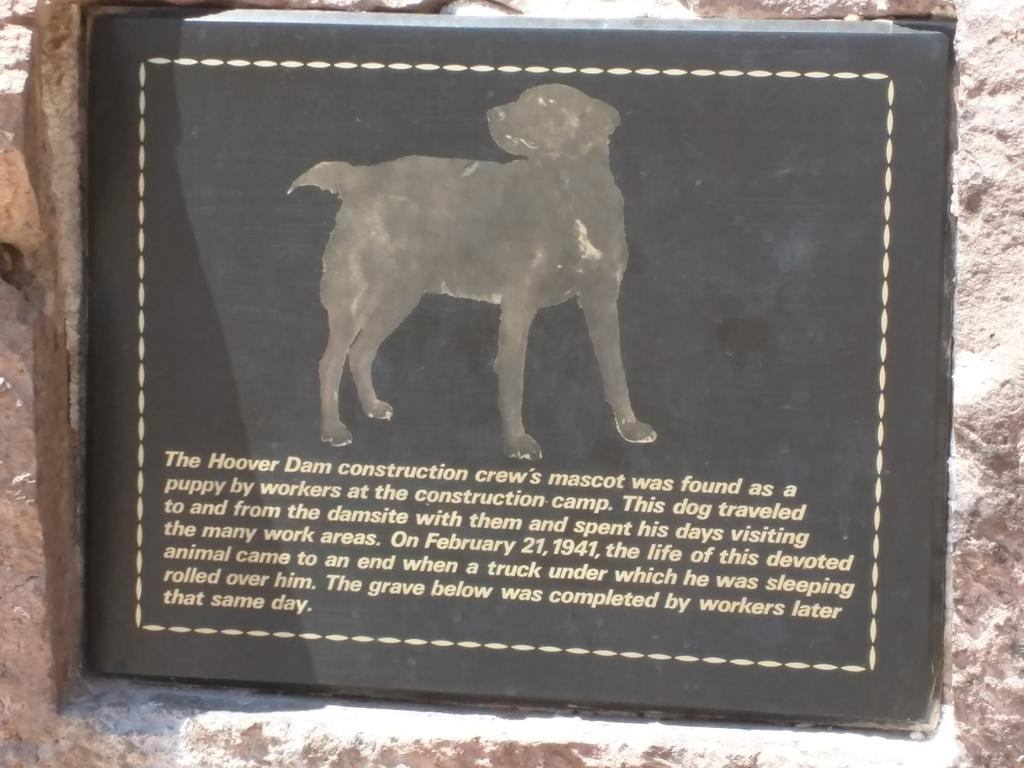What is the main subject of the image? The main subject of the image is a grave. What type of grave is it? The grave is for a dog. What is on the grave? There is a black color plate on the grave. What is depicted on the plate? There is an image of a dog on the plate. What information is provided about the dog on the plate? There are lines written about the dog under the image. How does the grave offer quietness to the surrounding environment? The grave itself does not offer quietness; it is a stationary object in the image. The quietness or lack thereof in the surrounding environment is not determined by the presence of the grave. 